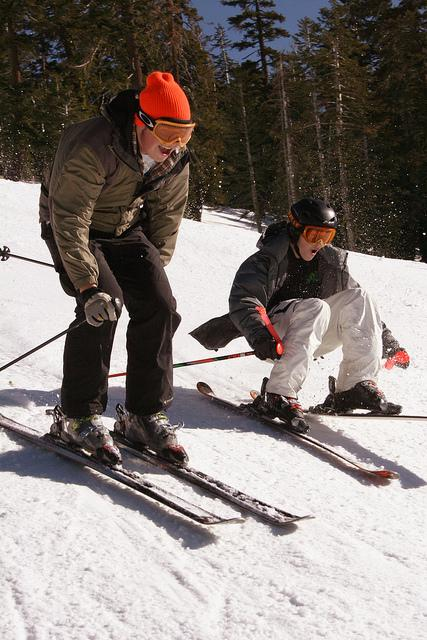What is this sport name? skiing 